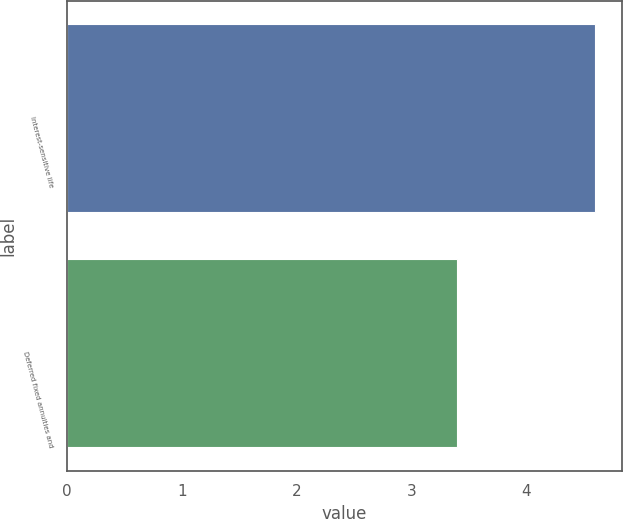<chart> <loc_0><loc_0><loc_500><loc_500><bar_chart><fcel>Interest-sensitive life<fcel>Deferred fixed annuities and<nl><fcel>4.6<fcel>3.4<nl></chart> 